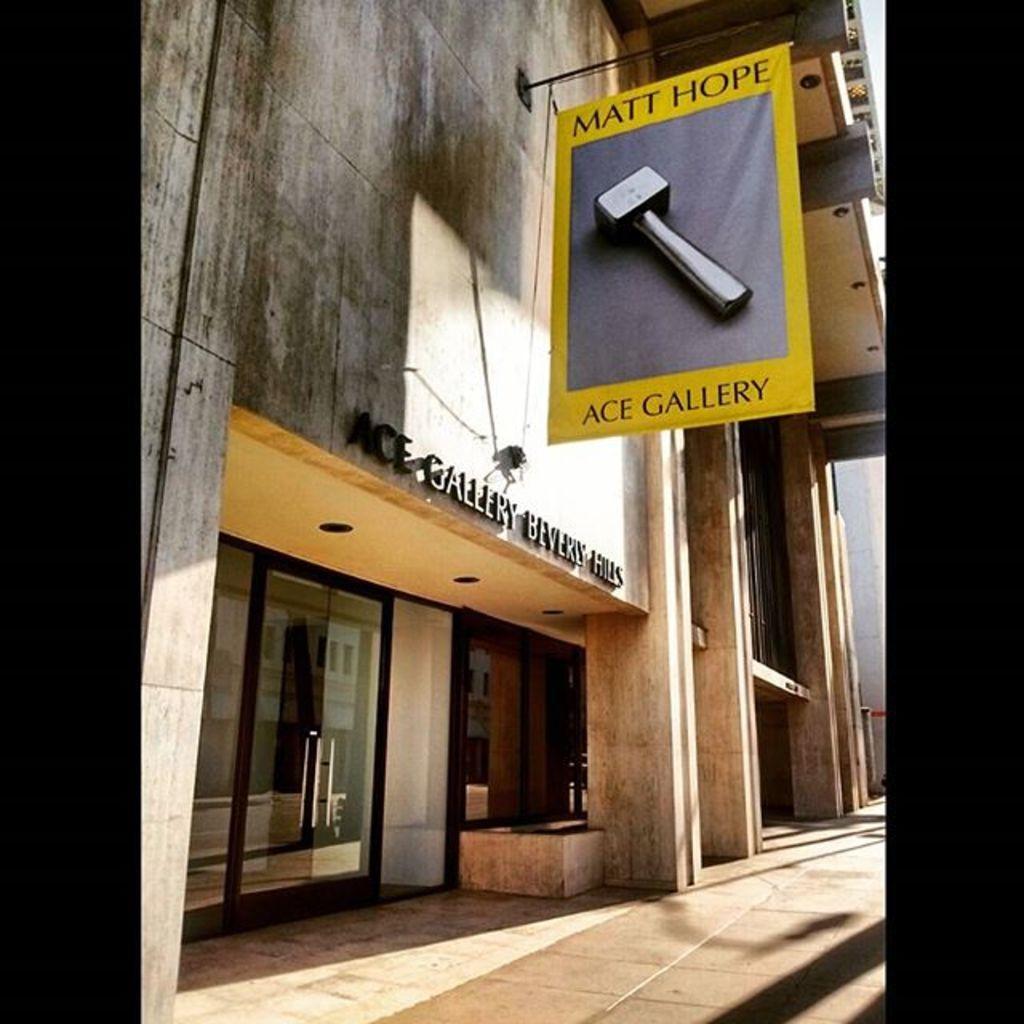How would you summarize this image in a sentence or two? In this image i can see a banner on which there is a hammer and i can see the glass door to the building. In the background i can see the sky, and i can see the sidewalk. 